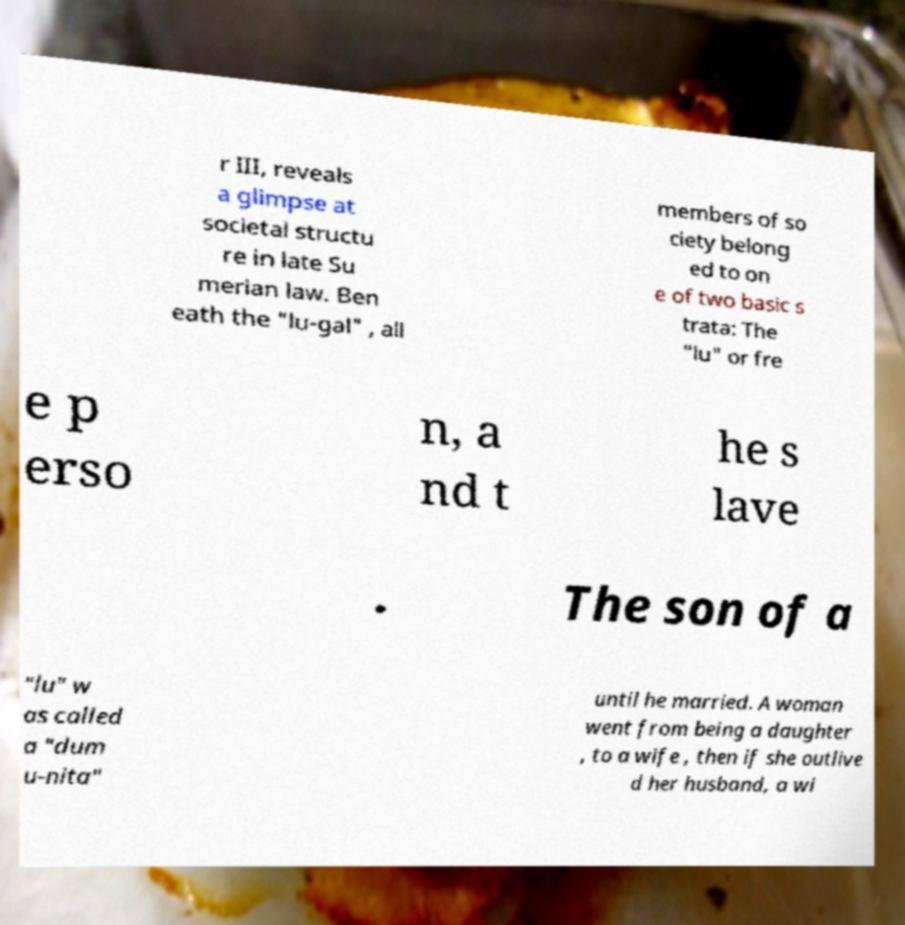I need the written content from this picture converted into text. Can you do that? r III, reveals a glimpse at societal structu re in late Su merian law. Ben eath the "lu-gal" , all members of so ciety belong ed to on e of two basic s trata: The "lu" or fre e p erso n, a nd t he s lave . The son of a "lu" w as called a "dum u-nita" until he married. A woman went from being a daughter , to a wife , then if she outlive d her husband, a wi 